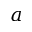Convert formula to latex. <formula><loc_0><loc_0><loc_500><loc_500>a</formula> 